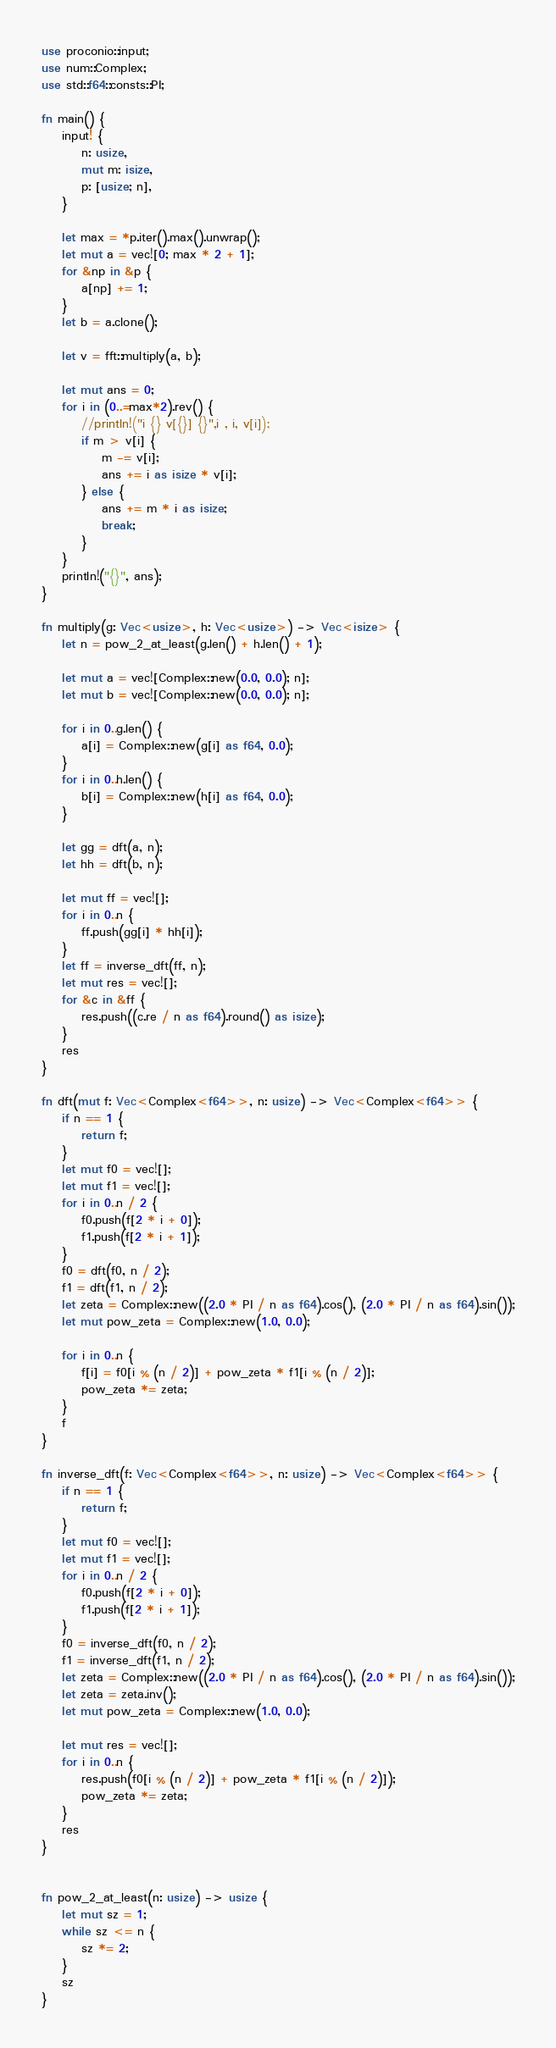<code> <loc_0><loc_0><loc_500><loc_500><_Rust_>use proconio::input;
use num::Complex;
use std::f64::consts::PI;

fn main() {
    input! {
        n: usize,
        mut m: isize,
        p: [usize; n],
    }

    let max = *p.iter().max().unwrap();
    let mut a = vec![0; max * 2 + 1];
    for &np in &p {
        a[np] += 1;
    }
    let b = a.clone();

    let v = fft::multiply(a, b);

    let mut ans = 0;
    for i in (0..=max*2).rev() {
        //println!("i {} v[{}] {}",i , i, v[i]);
        if m > v[i] {
            m -= v[i];
            ans += i as isize * v[i];
        } else {
            ans += m * i as isize;
            break;
        }
    }
    println!("{}", ans);
}

fn multiply(g: Vec<usize>, h: Vec<usize>) -> Vec<isize> {
    let n = pow_2_at_least(g.len() + h.len() + 1);

    let mut a = vec![Complex::new(0.0, 0.0); n];
    let mut b = vec![Complex::new(0.0, 0.0); n];

    for i in 0..g.len() {
        a[i] = Complex::new(g[i] as f64, 0.0);
    }
    for i in 0..h.len() {
        b[i] = Complex::new(h[i] as f64, 0.0);
    }

    let gg = dft(a, n);
    let hh = dft(b, n);

    let mut ff = vec![];
    for i in 0..n {
        ff.push(gg[i] * hh[i]);
    }
    let ff = inverse_dft(ff, n);
    let mut res = vec![];
    for &c in &ff {
        res.push((c.re / n as f64).round() as isize);
    }
    res
}

fn dft(mut f: Vec<Complex<f64>>, n: usize) -> Vec<Complex<f64>> {
    if n == 1 {
        return f;
    }
    let mut f0 = vec![];
    let mut f1 = vec![];
    for i in 0..n / 2 {
        f0.push(f[2 * i + 0]);
        f1.push(f[2 * i + 1]);
    }
    f0 = dft(f0, n / 2);
    f1 = dft(f1, n / 2);
    let zeta = Complex::new((2.0 * PI / n as f64).cos(), (2.0 * PI / n as f64).sin());
    let mut pow_zeta = Complex::new(1.0, 0.0);

    for i in 0..n {
        f[i] = f0[i % (n / 2)] + pow_zeta * f1[i % (n / 2)];
        pow_zeta *= zeta;
    }
    f
}

fn inverse_dft(f: Vec<Complex<f64>>, n: usize) -> Vec<Complex<f64>> {
    if n == 1 {
        return f;
    }
    let mut f0 = vec![];
    let mut f1 = vec![];
    for i in 0..n / 2 {
        f0.push(f[2 * i + 0]);
        f1.push(f[2 * i + 1]);
    }
    f0 = inverse_dft(f0, n / 2);
    f1 = inverse_dft(f1, n / 2);
    let zeta = Complex::new((2.0 * PI / n as f64).cos(), (2.0 * PI / n as f64).sin());
    let zeta = zeta.inv();
    let mut pow_zeta = Complex::new(1.0, 0.0);

    let mut res = vec![];
    for i in 0..n {
        res.push(f0[i % (n / 2)] + pow_zeta * f1[i % (n / 2)]);
        pow_zeta *= zeta;
    }
    res
}


fn pow_2_at_least(n: usize) -> usize {
    let mut sz = 1;
    while sz <= n {
        sz *= 2;
    }
    sz
}
</code> 